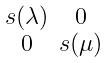Convert formula to latex. <formula><loc_0><loc_0><loc_500><loc_500>\begin{smallmatrix} s ( \lambda ) & 0 \\ 0 & s ( \mu ) \end{smallmatrix}</formula> 